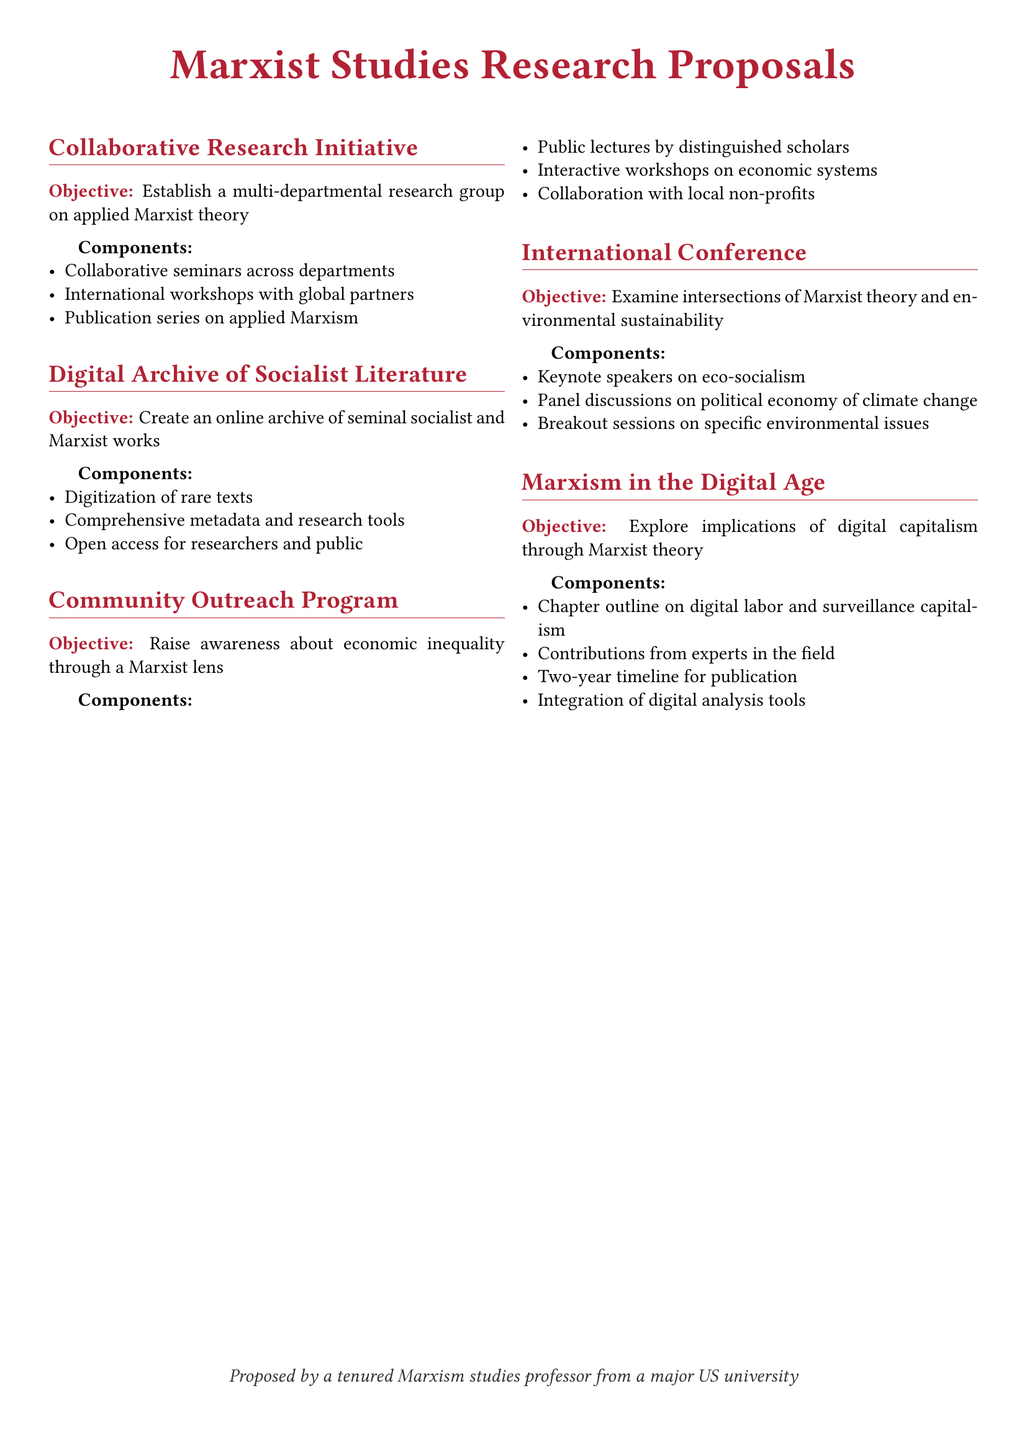What is the objective of the Collaborative Research Initiative? The objective is to establish a multi-departmental research group on applied Marxist theory.
Answer: Establish a multi-departmental research group on applied Marxist theory What components are included in the Digital Archive of Socialist Literature? The components include digitization of rare texts, comprehensive metadata and research tools, and open access for researchers and public.
Answer: Digitization of rare texts, comprehensive metadata and research tools, open access for researchers and public How many components are listed under the Community Outreach Program? The number of components can be found by counting the items listed, which include three distinct elements.
Answer: Three What is a primary focus of the International Conference? The primary focus is examining the intersections of Marxist theory and environmental sustainability.
Answer: Examining the intersections of Marxist theory and environmental sustainability What digital phenomenon is being explored in the project titled "Marxism in the Digital Age"? The project explores the implications of digital capitalism through Marxist theory.
Answer: The implications of digital capitalism through Marxist theory What types of activities are included in the Community Outreach Program? The activities listed include public lectures, interactive workshops, and collaboration with local non-profits.
Answer: Public lectures, interactive workshops, collaboration with local non-profits What type of publication series is mentioned in the Collaborative Research Initiative? The Collaborative Research Initiative mentions a publication series on applied Marxism.
Answer: A publication series on applied Marxism How long is the proposed timeline for the publication in the project "Marxism in the Digital Age"? The timeline specified is two years for publication.
Answer: Two-year timeline for publication 